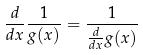Convert formula to latex. <formula><loc_0><loc_0><loc_500><loc_500>\frac { d } { d x } \frac { 1 } { g ( x ) } = \frac { 1 } { \frac { d } { d x } g ( x ) }</formula> 